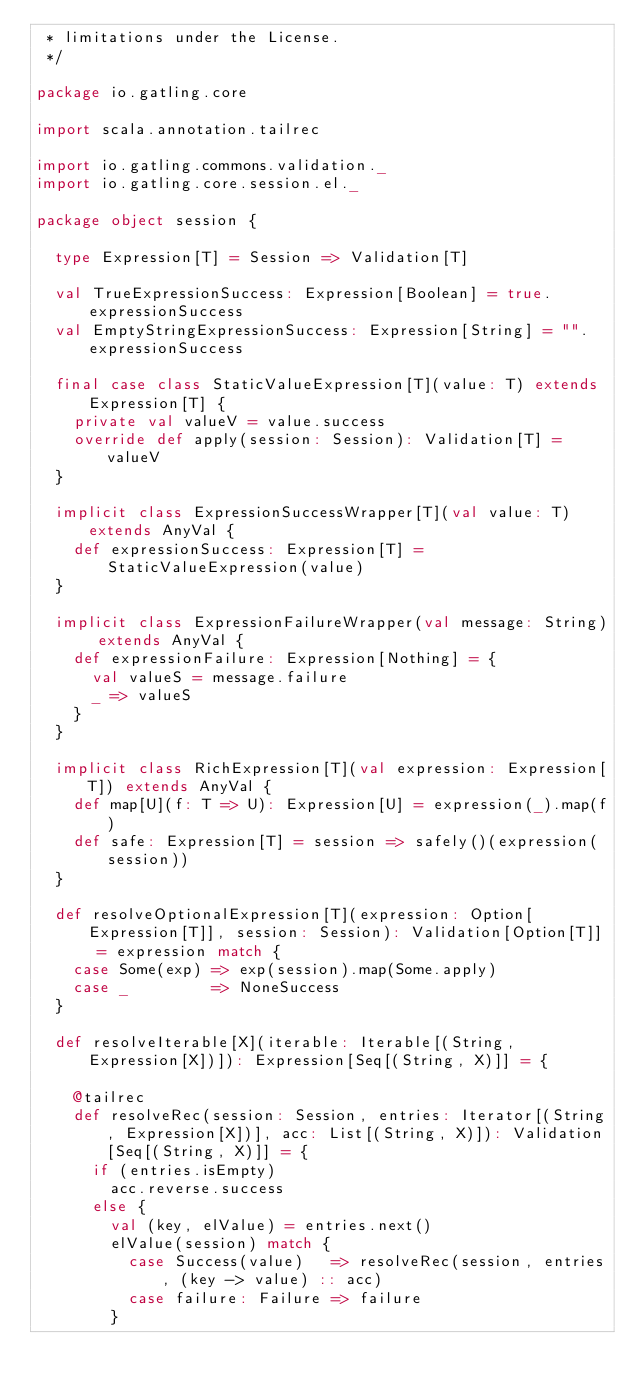<code> <loc_0><loc_0><loc_500><loc_500><_Scala_> * limitations under the License.
 */

package io.gatling.core

import scala.annotation.tailrec

import io.gatling.commons.validation._
import io.gatling.core.session.el._

package object session {

  type Expression[T] = Session => Validation[T]

  val TrueExpressionSuccess: Expression[Boolean] = true.expressionSuccess
  val EmptyStringExpressionSuccess: Expression[String] = "".expressionSuccess

  final case class StaticValueExpression[T](value: T) extends Expression[T] {
    private val valueV = value.success
    override def apply(session: Session): Validation[T] = valueV
  }

  implicit class ExpressionSuccessWrapper[T](val value: T) extends AnyVal {
    def expressionSuccess: Expression[T] = StaticValueExpression(value)
  }

  implicit class ExpressionFailureWrapper(val message: String) extends AnyVal {
    def expressionFailure: Expression[Nothing] = {
      val valueS = message.failure
      _ => valueS
    }
  }

  implicit class RichExpression[T](val expression: Expression[T]) extends AnyVal {
    def map[U](f: T => U): Expression[U] = expression(_).map(f)
    def safe: Expression[T] = session => safely()(expression(session))
  }

  def resolveOptionalExpression[T](expression: Option[Expression[T]], session: Session): Validation[Option[T]] = expression match {
    case Some(exp) => exp(session).map(Some.apply)
    case _         => NoneSuccess
  }

  def resolveIterable[X](iterable: Iterable[(String, Expression[X])]): Expression[Seq[(String, X)]] = {

    @tailrec
    def resolveRec(session: Session, entries: Iterator[(String, Expression[X])], acc: List[(String, X)]): Validation[Seq[(String, X)]] = {
      if (entries.isEmpty)
        acc.reverse.success
      else {
        val (key, elValue) = entries.next()
        elValue(session) match {
          case Success(value)   => resolveRec(session, entries, (key -> value) :: acc)
          case failure: Failure => failure
        }</code> 